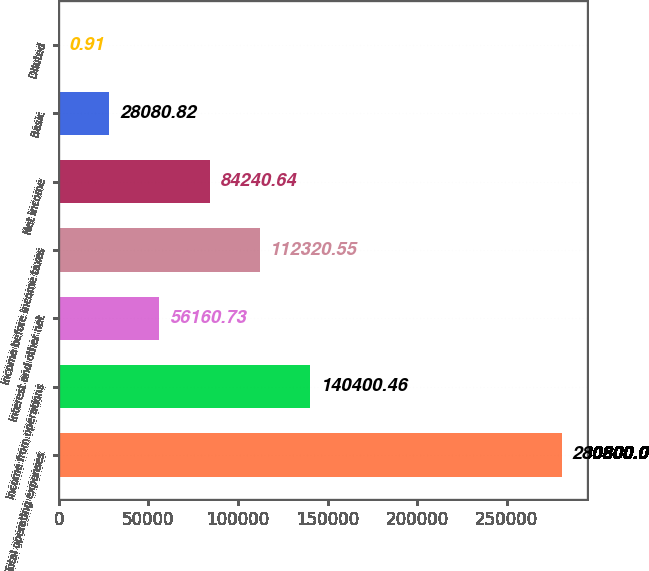Convert chart to OTSL. <chart><loc_0><loc_0><loc_500><loc_500><bar_chart><fcel>Total operating expenses<fcel>Income from operations<fcel>Interest and other net<fcel>Income before income taxes<fcel>Net income<fcel>Basic<fcel>Diluted<nl><fcel>280800<fcel>140400<fcel>56160.7<fcel>112321<fcel>84240.6<fcel>28080.8<fcel>0.91<nl></chart> 